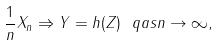<formula> <loc_0><loc_0><loc_500><loc_500>\frac { 1 } { n } X _ { n } \Rightarrow Y = h ( Z ) \ q a s n \to \infty ,</formula> 